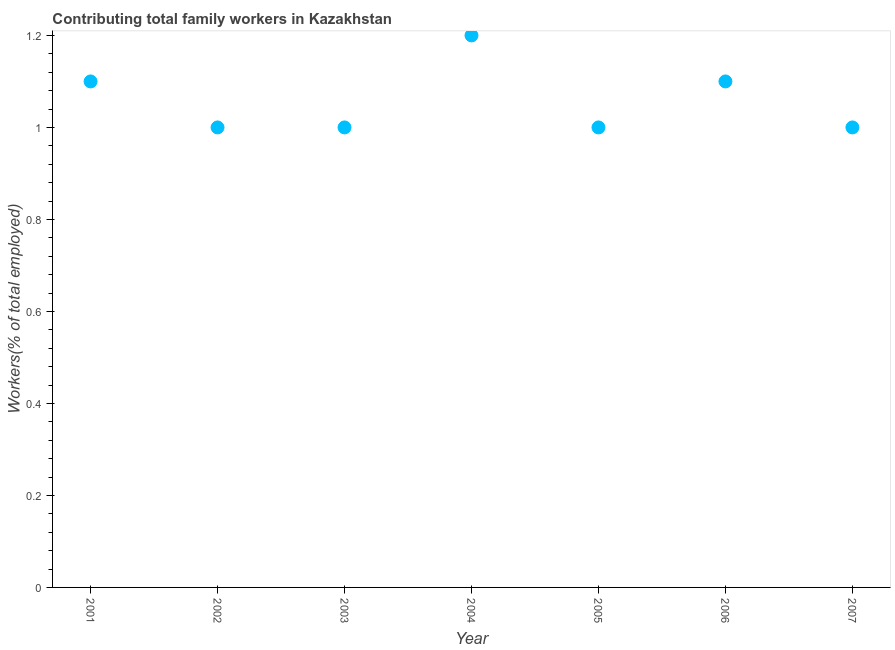Across all years, what is the maximum contributing family workers?
Keep it short and to the point. 1.2. Across all years, what is the minimum contributing family workers?
Provide a succinct answer. 1. What is the sum of the contributing family workers?
Offer a terse response. 7.4. What is the difference between the contributing family workers in 2005 and 2007?
Make the answer very short. 0. What is the average contributing family workers per year?
Your answer should be very brief. 1.06. In how many years, is the contributing family workers greater than 1 %?
Provide a short and direct response. 3. What is the ratio of the contributing family workers in 2005 to that in 2007?
Offer a terse response. 1. Is the contributing family workers in 2002 less than that in 2003?
Make the answer very short. No. Is the difference between the contributing family workers in 2004 and 2005 greater than the difference between any two years?
Make the answer very short. Yes. What is the difference between the highest and the second highest contributing family workers?
Provide a succinct answer. 0.1. Is the sum of the contributing family workers in 2004 and 2007 greater than the maximum contributing family workers across all years?
Keep it short and to the point. Yes. What is the difference between the highest and the lowest contributing family workers?
Your answer should be very brief. 0.2. In how many years, is the contributing family workers greater than the average contributing family workers taken over all years?
Your response must be concise. 3. Does the contributing family workers monotonically increase over the years?
Make the answer very short. No. What is the difference between two consecutive major ticks on the Y-axis?
Offer a terse response. 0.2. What is the title of the graph?
Ensure brevity in your answer.  Contributing total family workers in Kazakhstan. What is the label or title of the Y-axis?
Your answer should be very brief. Workers(% of total employed). What is the Workers(% of total employed) in 2001?
Your answer should be very brief. 1.1. What is the Workers(% of total employed) in 2004?
Keep it short and to the point. 1.2. What is the Workers(% of total employed) in 2005?
Offer a terse response. 1. What is the Workers(% of total employed) in 2006?
Provide a succinct answer. 1.1. What is the Workers(% of total employed) in 2007?
Offer a very short reply. 1. What is the difference between the Workers(% of total employed) in 2001 and 2005?
Make the answer very short. 0.1. What is the difference between the Workers(% of total employed) in 2001 and 2006?
Your response must be concise. 0. What is the difference between the Workers(% of total employed) in 2002 and 2004?
Your answer should be very brief. -0.2. What is the difference between the Workers(% of total employed) in 2002 and 2006?
Ensure brevity in your answer.  -0.1. What is the difference between the Workers(% of total employed) in 2002 and 2007?
Offer a terse response. 0. What is the difference between the Workers(% of total employed) in 2003 and 2004?
Your answer should be compact. -0.2. What is the difference between the Workers(% of total employed) in 2003 and 2006?
Make the answer very short. -0.1. What is the difference between the Workers(% of total employed) in 2003 and 2007?
Keep it short and to the point. 0. What is the difference between the Workers(% of total employed) in 2005 and 2006?
Your answer should be compact. -0.1. What is the difference between the Workers(% of total employed) in 2005 and 2007?
Your response must be concise. 0. What is the ratio of the Workers(% of total employed) in 2001 to that in 2004?
Ensure brevity in your answer.  0.92. What is the ratio of the Workers(% of total employed) in 2001 to that in 2007?
Provide a short and direct response. 1.1. What is the ratio of the Workers(% of total employed) in 2002 to that in 2004?
Keep it short and to the point. 0.83. What is the ratio of the Workers(% of total employed) in 2002 to that in 2005?
Your answer should be compact. 1. What is the ratio of the Workers(% of total employed) in 2002 to that in 2006?
Offer a very short reply. 0.91. What is the ratio of the Workers(% of total employed) in 2002 to that in 2007?
Make the answer very short. 1. What is the ratio of the Workers(% of total employed) in 2003 to that in 2004?
Provide a succinct answer. 0.83. What is the ratio of the Workers(% of total employed) in 2003 to that in 2006?
Ensure brevity in your answer.  0.91. What is the ratio of the Workers(% of total employed) in 2004 to that in 2005?
Your answer should be compact. 1.2. What is the ratio of the Workers(% of total employed) in 2004 to that in 2006?
Ensure brevity in your answer.  1.09. What is the ratio of the Workers(% of total employed) in 2005 to that in 2006?
Your answer should be very brief. 0.91. 